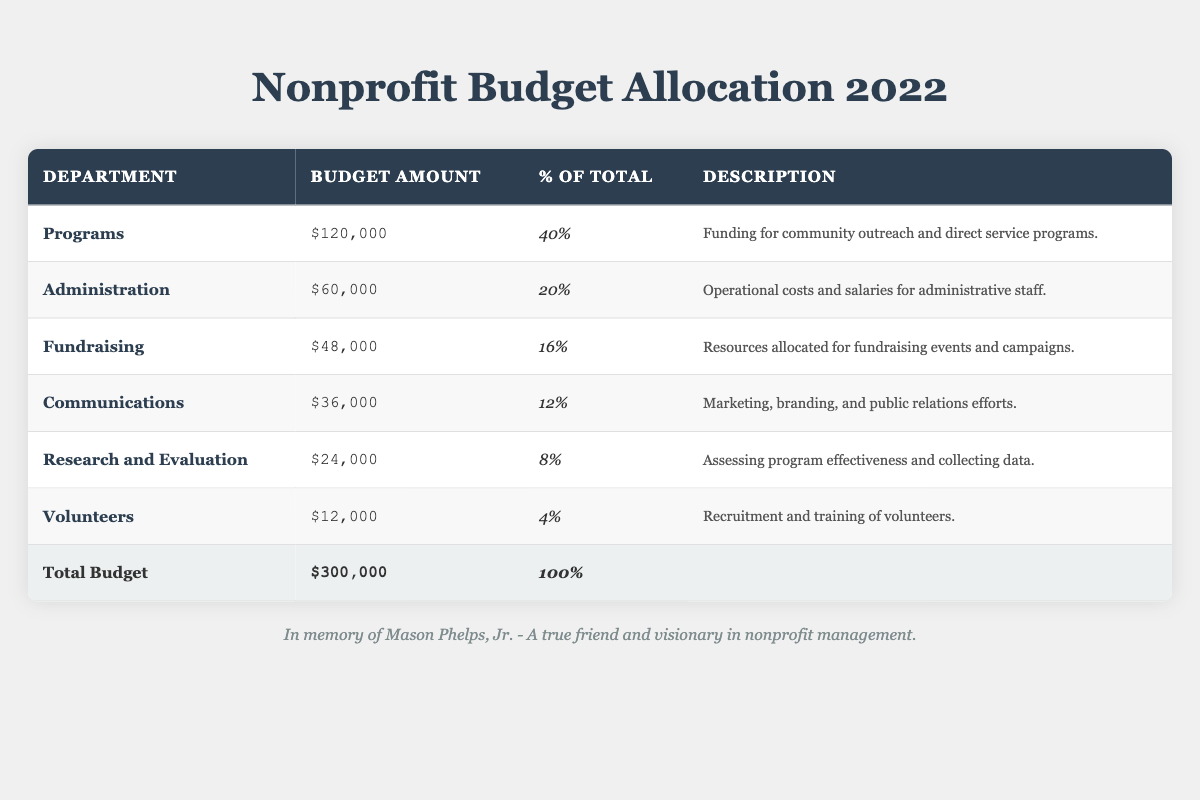What is the total budget allocated for the nonprofit organization in 2022? The table clearly states the total budget at the bottom, listed as $300,000.
Answer: $300,000 Which department received the highest budget allocation? By comparing the budget amounts for each department, Programs with $120,000 is the highest.
Answer: Programs What percentage of the total budget is allocated to Administration? The table indicates that Administration received $60,000, which is 20% of the total budget.
Answer: 20% How much more budget is allocated to Programs than to Communications? Programs received $120,000 and Communications received $36,000, so the difference is $120,000 - $36,000 = $84,000.
Answer: $84,000 What is the average budget allocation for all departments? To find the average, sum the budget amounts ($120,000 + $60,000 + $48,000 + $36,000 + $24,000 + $12,000 = $300,000) and divide by the number of departments (6): $300,000 / 6 = $50,000.
Answer: $50,000 Is the budget for Fundraising greater than the budget for Volunteers? Fundraising has a budget of $48,000 while Volunteers have $12,000. Since $48,000 is greater than $12,000, the statement is true.
Answer: Yes If you combine the budget for Research and Evaluation and Volunteers, what is the total? Research and Evaluation has a budget of $24,000 and Volunteers has $12,000. Therefore, the combined total is $24,000 + $12,000 = $36,000.
Answer: $36,000 What proportion of the total budget is allocated to Fundraising compared to Programs? Fundraising has $48,000 (16% of total), while Programs has $120,000 (40% of total), thus the ratio is $48,000 / $120,000 = 0.4, so Fundraising is 40% of Programs' budget.
Answer: 40% How much does the sum of the budgets for Communications and Research and Evaluation compare to the budget for Administration? Communications has $36,000 and Research and Evaluation has $24,000, totaling $36,000 + $24,000 = $60,000. This is equal to the Administration budget of $60,000.
Answer: Equal If the budget for Volunteers were to increase by 50%, what would be the new budget amount? Volunteers' current budget is $12,000, a 50% increase means adding $12,000 * 0.5 = $6,000. Thus, the new budget would be $12,000 + $6,000 = $18,000.
Answer: $18,000 Considering the total budget of $300,000, what is the budget allocated to departments other than Programs? The total budget for departments other than Programs is $300,000 - $120,000 = $180,000.
Answer: $180,000 